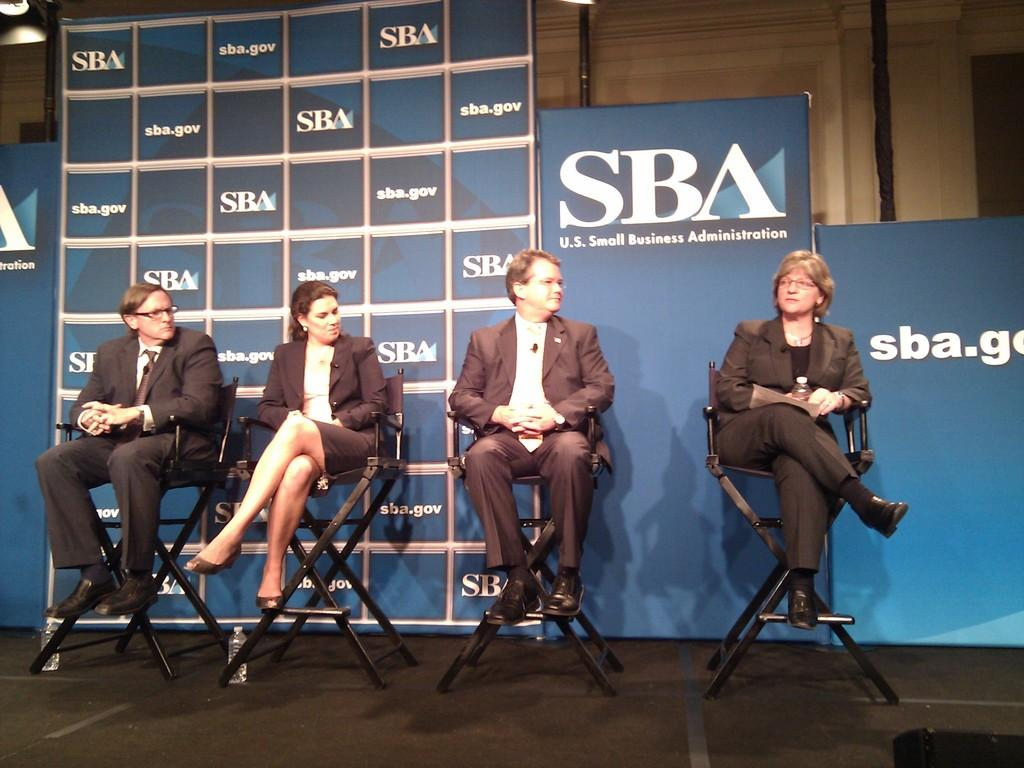Who or what can be seen in the image? There are people in the image. What are the people doing in the image? The people are sitting on chairs. What type of stone is being used as a chair by the bears in the image? There are no bears or stones present in the image; it features people sitting on chairs. 